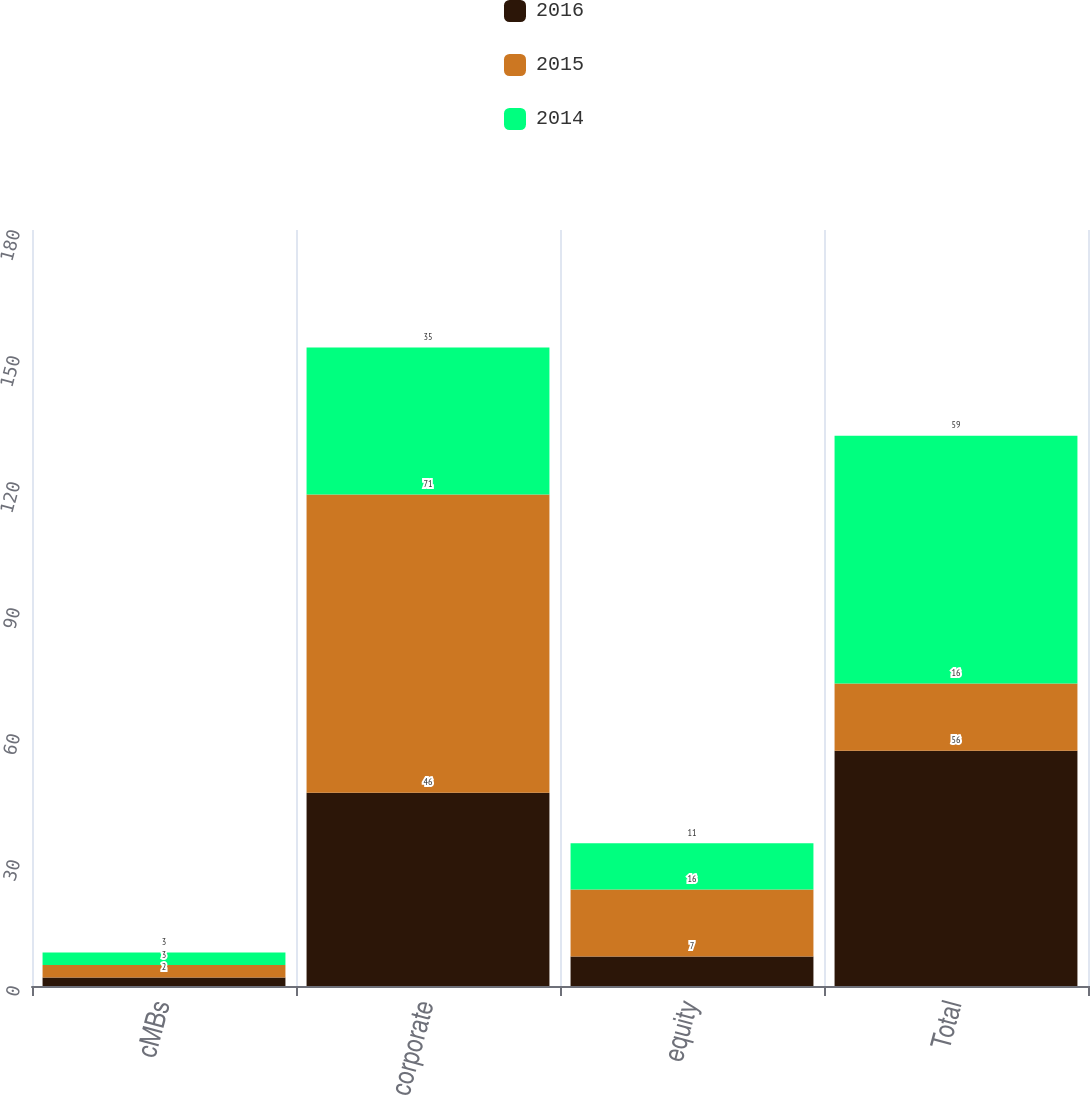<chart> <loc_0><loc_0><loc_500><loc_500><stacked_bar_chart><ecel><fcel>cMBs<fcel>corporate<fcel>equity<fcel>Total<nl><fcel>2016<fcel>2<fcel>46<fcel>7<fcel>56<nl><fcel>2015<fcel>3<fcel>71<fcel>16<fcel>16<nl><fcel>2014<fcel>3<fcel>35<fcel>11<fcel>59<nl></chart> 